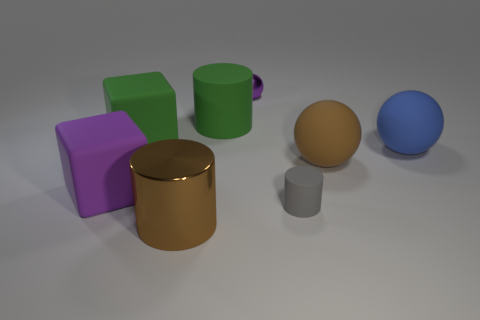There is a object that is the same color as the big rubber cylinder; what is its material?
Your answer should be compact. Rubber. There is another thing that is the same size as the gray object; what is it made of?
Offer a terse response. Metal. What number of things are either large rubber balls or big cyan rubber balls?
Offer a very short reply. 2. What number of metallic objects are on the left side of the tiny purple ball and behind the large brown cylinder?
Ensure brevity in your answer.  0. Are there fewer gray rubber cylinders that are to the left of the gray object than brown metallic balls?
Ensure brevity in your answer.  No. There is a gray object that is the same size as the metallic sphere; what shape is it?
Your response must be concise. Cylinder. What number of other things are there of the same color as the large matte cylinder?
Give a very brief answer. 1. Is the brown metallic cylinder the same size as the purple sphere?
Ensure brevity in your answer.  No. What number of objects are either large green cubes or things that are behind the metal cylinder?
Make the answer very short. 7. Are there fewer green things that are to the left of the big blue matte object than objects in front of the green cylinder?
Offer a very short reply. Yes. 